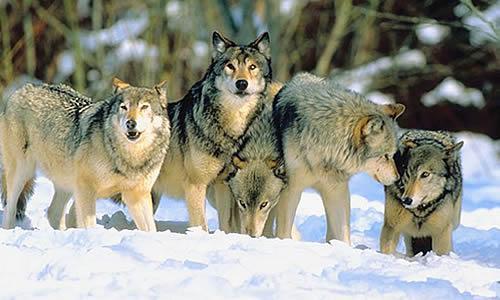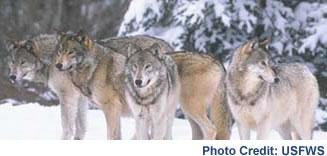The first image is the image on the left, the second image is the image on the right. Analyze the images presented: Is the assertion "There are exactly 9 wolves." valid? Answer yes or no. Yes. The first image is the image on the left, the second image is the image on the right. Given the left and right images, does the statement "In the right image, there are four wolves in the snow." hold true? Answer yes or no. Yes. 